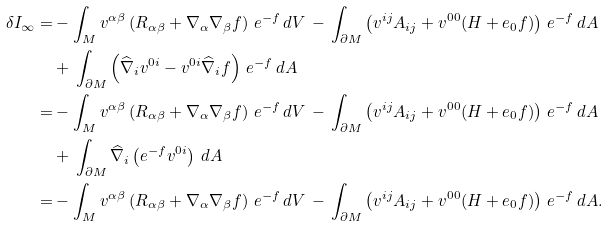Convert formula to latex. <formula><loc_0><loc_0><loc_500><loc_500>\delta I _ { \infty } = & - \int _ { M } v ^ { \alpha \beta } \left ( R _ { \alpha \beta } + \nabla _ { \alpha } \nabla _ { \beta } f \right ) \, e ^ { - f } \, d V \, - \, \int _ { \partial M } \left ( v ^ { i j } A _ { i j } + v ^ { 0 0 } ( H + e _ { 0 } f ) \right ) \, e ^ { - f } \, d A \\ & + \, \int _ { \partial M } \left ( \widehat { \nabla } _ { i } v ^ { 0 i } - v ^ { 0 i } \widehat { \nabla } _ { i } f \right ) \, e ^ { - f } \, d A \\ = & - \int _ { M } v ^ { \alpha \beta } \left ( R _ { \alpha \beta } + \nabla _ { \alpha } \nabla _ { \beta } f \right ) \, e ^ { - f } \, d V \, - \, \int _ { \partial M } \left ( v ^ { i j } A _ { i j } + v ^ { 0 0 } ( H + e _ { 0 } f ) \right ) \, e ^ { - f } \, d A \\ & + \, \int _ { \partial M } \widehat { \nabla } _ { i } \left ( e ^ { - f } v ^ { 0 i } \right ) \, d A \\ = & - \int _ { M } v ^ { \alpha \beta } \left ( R _ { \alpha \beta } + \nabla _ { \alpha } \nabla _ { \beta } f \right ) \, e ^ { - f } \, d V \, - \, \int _ { \partial M } \left ( v ^ { i j } A _ { i j } + v ^ { 0 0 } ( H + e _ { 0 } f ) \right ) \, e ^ { - f } \, d A .</formula> 